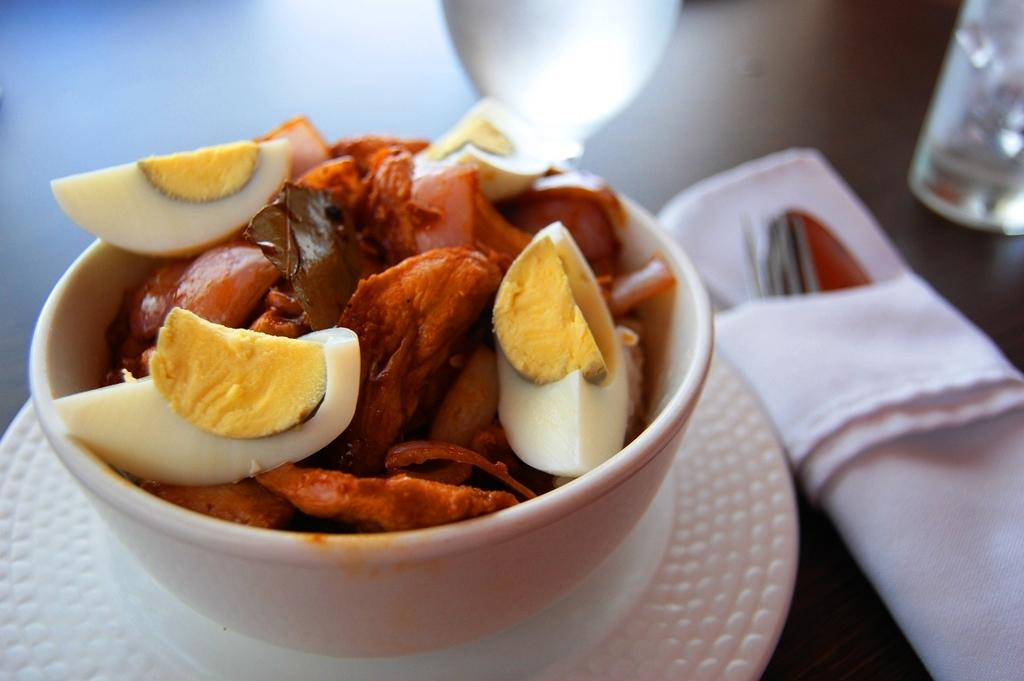What is placed on the bowl in the image? There is an eatable item placed on a bowl in the image. What utensil is visible in the image? A spoon is visible in the image. What item can be seen on the table in the image? There is a tissue on the table in the image. What type of treatment is being administered to the eatable item in the image? There is no treatment being administered to the eatable item in the image; it is simply placed on a bowl. 